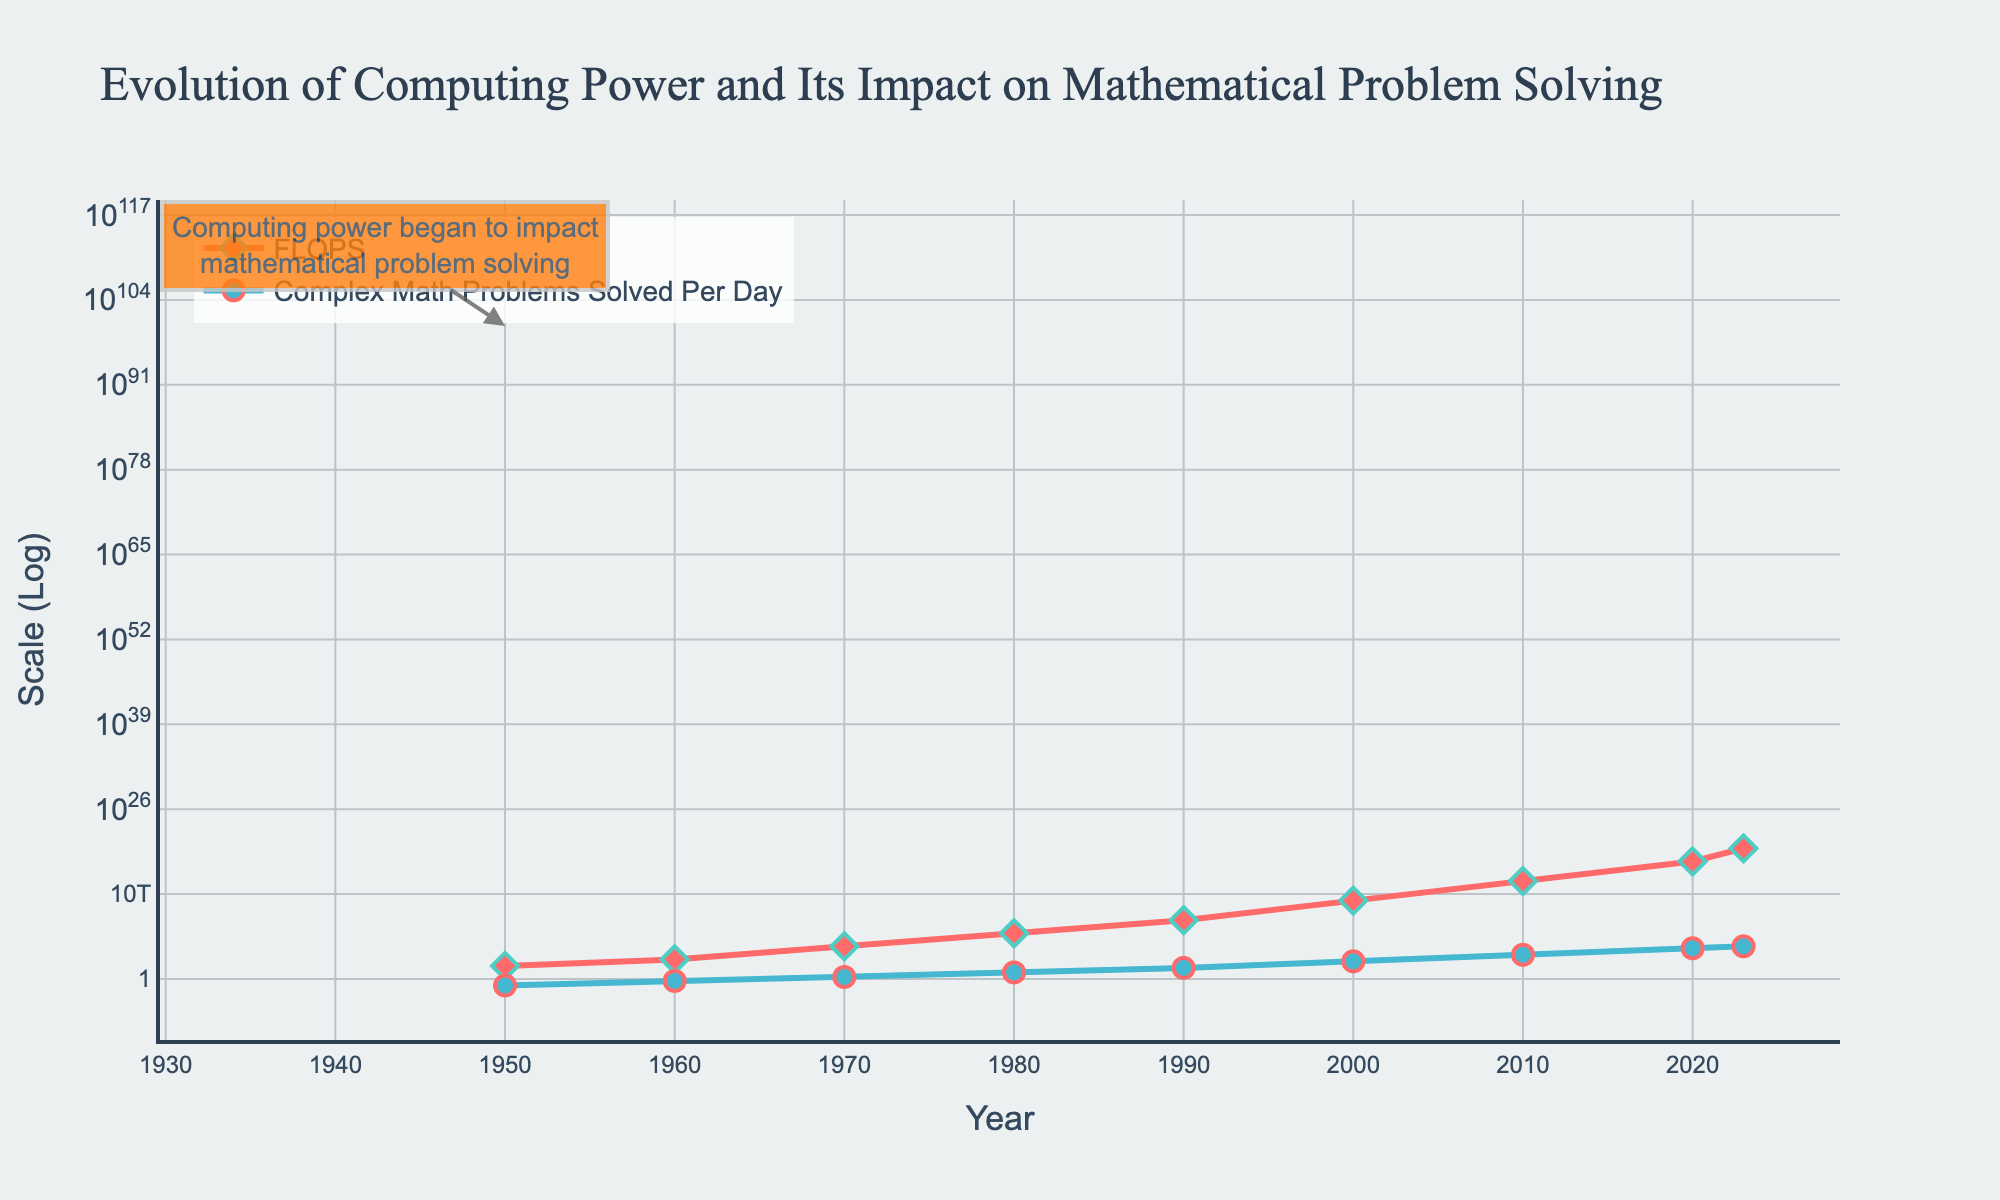What trend is observed in the FLOPS values from 1950 to 2023? Observing the line chart, the FLOPS values exhibit an exponential increase over time, indicating consistent improvements in computational power.
Answer: Exponential increase How many more complex mathematical problems were solved per day in 2020 compared to 1950? In 1950, approximately 0.1 problems were solved daily. In 2020, this number increased to 50,000. Therefore, the difference is 50000 - 0.1 = 49999.9.
Answer: 49999.9 Which year showed the largest single-decade increase in computing power, as measured in FLOPS? From 1990 to 2000, the FLOPS increased from 1e+9 to 1e+12, a difference of 1e+12 - 1e+9 = 999e+9, making it the decade with the largest increase.
Answer: 1990 to 2000 How does the rate of solving complex mathematical problems change from 2010 to 2023? In 2010, 5000 problems were solved per day which increased to 100000 by 2023. To see the change rate: 100000 - 5000 = 95000.
Answer: Increased by 95000 What is the relationship between the number of FLOPS and complex mathematical problems solved per day in 1980? In 1980, the FLOPS value was at 1e+7 and the problems solved per day were 10. This shows that while the computing power is increasing, its impact on problems solved is substantial.
Answer: Positive correlation Identify the color and shape of markers representing FLOPS. The markers for FLOPS are diamond-shaped and colored predominantly in red.
Answer: Red, diamond-shaped Which data series uses circular markers, and what color are they? The series representing "Complex Math Problems Solved Per Day" uses circular markers colored blue.
Answer: Complex Math Problems Solved Per Day, blue What annotation is present in the figure, and to which year does it correspond? The annotation highlights 1950, indicating that computing power began to impact mathematical problem solving from that year.
Answer: "Computing power began to impact mathematical problem solving", 1950 What is the difference in the number of complex mathematical problems solved per day between 1990 and 2000? From the figure, in 1990, 50 problems were solved daily, whereas in 2000, it increased to 500. Thus, the difference is: 500 - 50 = 450.
Answer: 450 Estimate the FLOPS growth from 2000 to 2010 and how it correlates with the increase in solved problems per day. FLOPS increased from 1e+12 in 2000 to 1e+15 in 2010 (increase of 999e+12). Simultaneously, the problems solved per day increased from 500 to 5000. Both variables exhibit exponential growth.
Answer: Exponential growth in both FLOPS and solved problems 